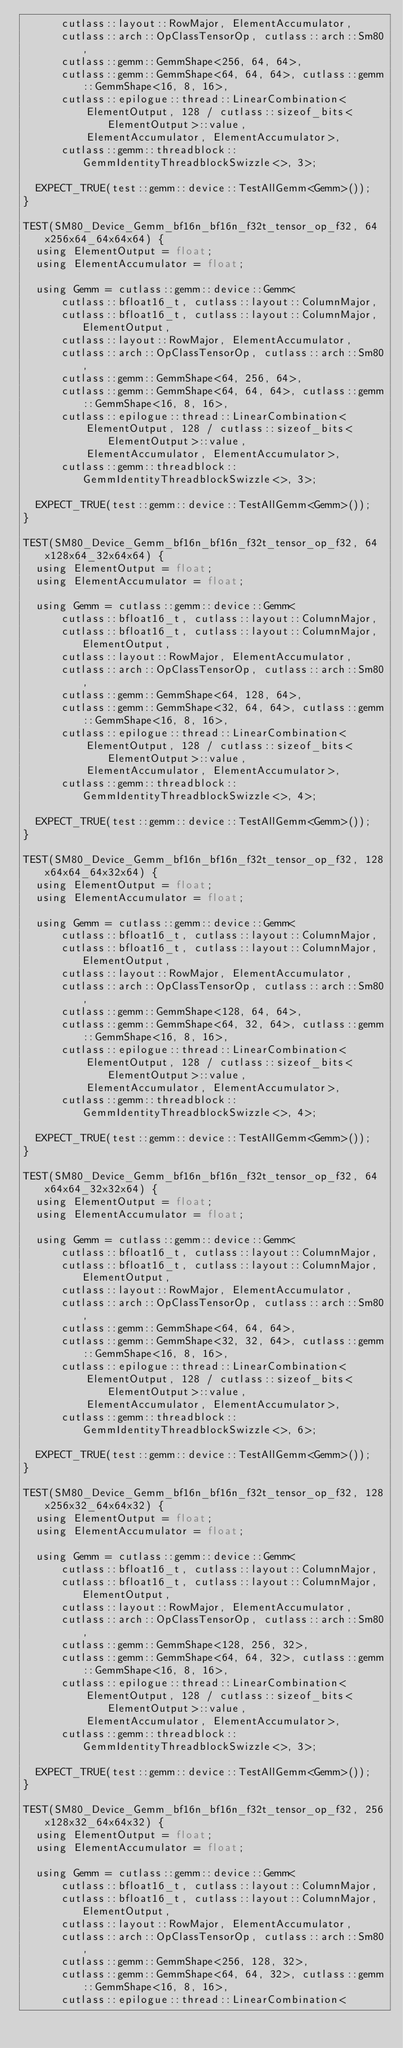<code> <loc_0><loc_0><loc_500><loc_500><_Cuda_>      cutlass::layout::RowMajor, ElementAccumulator,
      cutlass::arch::OpClassTensorOp, cutlass::arch::Sm80,
      cutlass::gemm::GemmShape<256, 64, 64>,
      cutlass::gemm::GemmShape<64, 64, 64>, cutlass::gemm::GemmShape<16, 8, 16>,
      cutlass::epilogue::thread::LinearCombination<
          ElementOutput, 128 / cutlass::sizeof_bits<ElementOutput>::value,
          ElementAccumulator, ElementAccumulator>,
      cutlass::gemm::threadblock::GemmIdentityThreadblockSwizzle<>, 3>;

  EXPECT_TRUE(test::gemm::device::TestAllGemm<Gemm>());
}

TEST(SM80_Device_Gemm_bf16n_bf16n_f32t_tensor_op_f32, 64x256x64_64x64x64) {
  using ElementOutput = float;
  using ElementAccumulator = float;

  using Gemm = cutlass::gemm::device::Gemm<
      cutlass::bfloat16_t, cutlass::layout::ColumnMajor,
      cutlass::bfloat16_t, cutlass::layout::ColumnMajor, ElementOutput,
      cutlass::layout::RowMajor, ElementAccumulator,
      cutlass::arch::OpClassTensorOp, cutlass::arch::Sm80,
      cutlass::gemm::GemmShape<64, 256, 64>,
      cutlass::gemm::GemmShape<64, 64, 64>, cutlass::gemm::GemmShape<16, 8, 16>,
      cutlass::epilogue::thread::LinearCombination<
          ElementOutput, 128 / cutlass::sizeof_bits<ElementOutput>::value,
          ElementAccumulator, ElementAccumulator>,
      cutlass::gemm::threadblock::GemmIdentityThreadblockSwizzle<>, 3>;

  EXPECT_TRUE(test::gemm::device::TestAllGemm<Gemm>());
}

TEST(SM80_Device_Gemm_bf16n_bf16n_f32t_tensor_op_f32, 64x128x64_32x64x64) {
  using ElementOutput = float;
  using ElementAccumulator = float;

  using Gemm = cutlass::gemm::device::Gemm<
      cutlass::bfloat16_t, cutlass::layout::ColumnMajor,
      cutlass::bfloat16_t, cutlass::layout::ColumnMajor, ElementOutput,
      cutlass::layout::RowMajor, ElementAccumulator,
      cutlass::arch::OpClassTensorOp, cutlass::arch::Sm80,
      cutlass::gemm::GemmShape<64, 128, 64>,
      cutlass::gemm::GemmShape<32, 64, 64>, cutlass::gemm::GemmShape<16, 8, 16>,
      cutlass::epilogue::thread::LinearCombination<
          ElementOutput, 128 / cutlass::sizeof_bits<ElementOutput>::value,
          ElementAccumulator, ElementAccumulator>,
      cutlass::gemm::threadblock::GemmIdentityThreadblockSwizzle<>, 4>;

  EXPECT_TRUE(test::gemm::device::TestAllGemm<Gemm>());
}

TEST(SM80_Device_Gemm_bf16n_bf16n_f32t_tensor_op_f32, 128x64x64_64x32x64) {
  using ElementOutput = float;
  using ElementAccumulator = float;

  using Gemm = cutlass::gemm::device::Gemm<
      cutlass::bfloat16_t, cutlass::layout::ColumnMajor,
      cutlass::bfloat16_t, cutlass::layout::ColumnMajor, ElementOutput,
      cutlass::layout::RowMajor, ElementAccumulator,
      cutlass::arch::OpClassTensorOp, cutlass::arch::Sm80,
      cutlass::gemm::GemmShape<128, 64, 64>,
      cutlass::gemm::GemmShape<64, 32, 64>, cutlass::gemm::GemmShape<16, 8, 16>,
      cutlass::epilogue::thread::LinearCombination<
          ElementOutput, 128 / cutlass::sizeof_bits<ElementOutput>::value,
          ElementAccumulator, ElementAccumulator>,
      cutlass::gemm::threadblock::GemmIdentityThreadblockSwizzle<>, 4>;

  EXPECT_TRUE(test::gemm::device::TestAllGemm<Gemm>());
}

TEST(SM80_Device_Gemm_bf16n_bf16n_f32t_tensor_op_f32, 64x64x64_32x32x64) {
  using ElementOutput = float;
  using ElementAccumulator = float;

  using Gemm = cutlass::gemm::device::Gemm<
      cutlass::bfloat16_t, cutlass::layout::ColumnMajor,
      cutlass::bfloat16_t, cutlass::layout::ColumnMajor, ElementOutput,
      cutlass::layout::RowMajor, ElementAccumulator,
      cutlass::arch::OpClassTensorOp, cutlass::arch::Sm80,
      cutlass::gemm::GemmShape<64, 64, 64>,
      cutlass::gemm::GemmShape<32, 32, 64>, cutlass::gemm::GemmShape<16, 8, 16>,
      cutlass::epilogue::thread::LinearCombination<
          ElementOutput, 128 / cutlass::sizeof_bits<ElementOutput>::value,
          ElementAccumulator, ElementAccumulator>,
      cutlass::gemm::threadblock::GemmIdentityThreadblockSwizzle<>, 6>;

  EXPECT_TRUE(test::gemm::device::TestAllGemm<Gemm>());
}

TEST(SM80_Device_Gemm_bf16n_bf16n_f32t_tensor_op_f32, 128x256x32_64x64x32) {
  using ElementOutput = float;
  using ElementAccumulator = float;

  using Gemm = cutlass::gemm::device::Gemm<
      cutlass::bfloat16_t, cutlass::layout::ColumnMajor,
      cutlass::bfloat16_t, cutlass::layout::ColumnMajor, ElementOutput,
      cutlass::layout::RowMajor, ElementAccumulator,
      cutlass::arch::OpClassTensorOp, cutlass::arch::Sm80,
      cutlass::gemm::GemmShape<128, 256, 32>,
      cutlass::gemm::GemmShape<64, 64, 32>, cutlass::gemm::GemmShape<16, 8, 16>,
      cutlass::epilogue::thread::LinearCombination<
          ElementOutput, 128 / cutlass::sizeof_bits<ElementOutput>::value,
          ElementAccumulator, ElementAccumulator>,
      cutlass::gemm::threadblock::GemmIdentityThreadblockSwizzle<>, 3>;

  EXPECT_TRUE(test::gemm::device::TestAllGemm<Gemm>());
}

TEST(SM80_Device_Gemm_bf16n_bf16n_f32t_tensor_op_f32, 256x128x32_64x64x32) {
  using ElementOutput = float;
  using ElementAccumulator = float;

  using Gemm = cutlass::gemm::device::Gemm<
      cutlass::bfloat16_t, cutlass::layout::ColumnMajor,
      cutlass::bfloat16_t, cutlass::layout::ColumnMajor, ElementOutput,
      cutlass::layout::RowMajor, ElementAccumulator,
      cutlass::arch::OpClassTensorOp, cutlass::arch::Sm80,
      cutlass::gemm::GemmShape<256, 128, 32>,
      cutlass::gemm::GemmShape<64, 64, 32>, cutlass::gemm::GemmShape<16, 8, 16>,
      cutlass::epilogue::thread::LinearCombination<</code> 